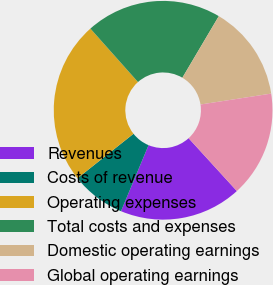<chart> <loc_0><loc_0><loc_500><loc_500><pie_chart><fcel>Revenues<fcel>Costs of revenue<fcel>Operating expenses<fcel>Total costs and expenses<fcel>Domestic operating earnings<fcel>Global operating earnings<nl><fcel>18.07%<fcel>8.03%<fcel>24.1%<fcel>20.08%<fcel>14.06%<fcel>15.66%<nl></chart> 